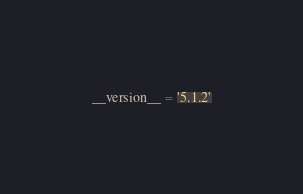Convert code to text. <code><loc_0><loc_0><loc_500><loc_500><_Python_>__version__ = '5.1.2'

</code> 